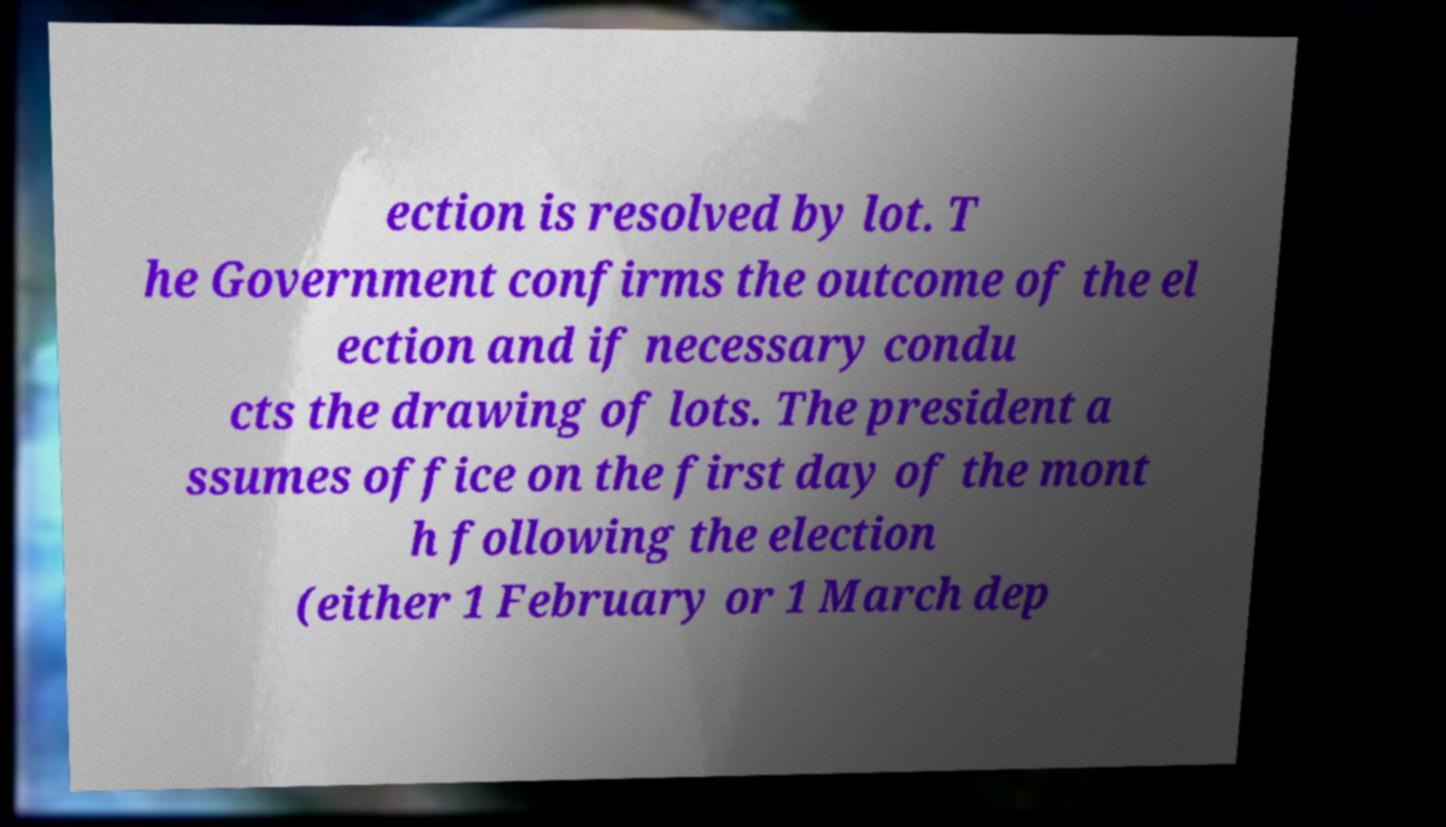What messages or text are displayed in this image? I need them in a readable, typed format. ection is resolved by lot. T he Government confirms the outcome of the el ection and if necessary condu cts the drawing of lots. The president a ssumes office on the first day of the mont h following the election (either 1 February or 1 March dep 